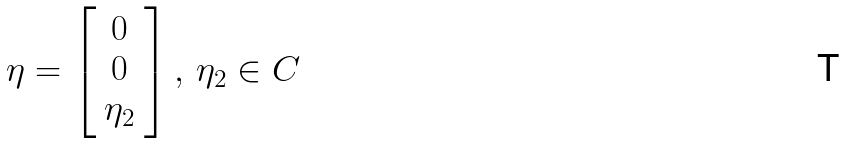<formula> <loc_0><loc_0><loc_500><loc_500>\eta = \left [ \begin{array} { c } 0 \\ 0 \\ \eta _ { 2 } \end{array} \right ] , \, \eta _ { 2 } \in { C }</formula> 